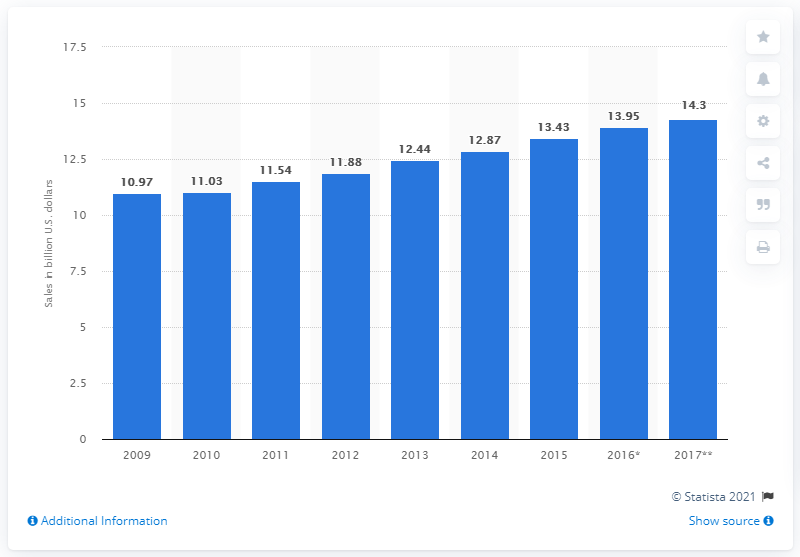Mention a couple of crucial points in this snapshot. In 2017, the forecasted sales for vending and non-store retailers were 14.3. 